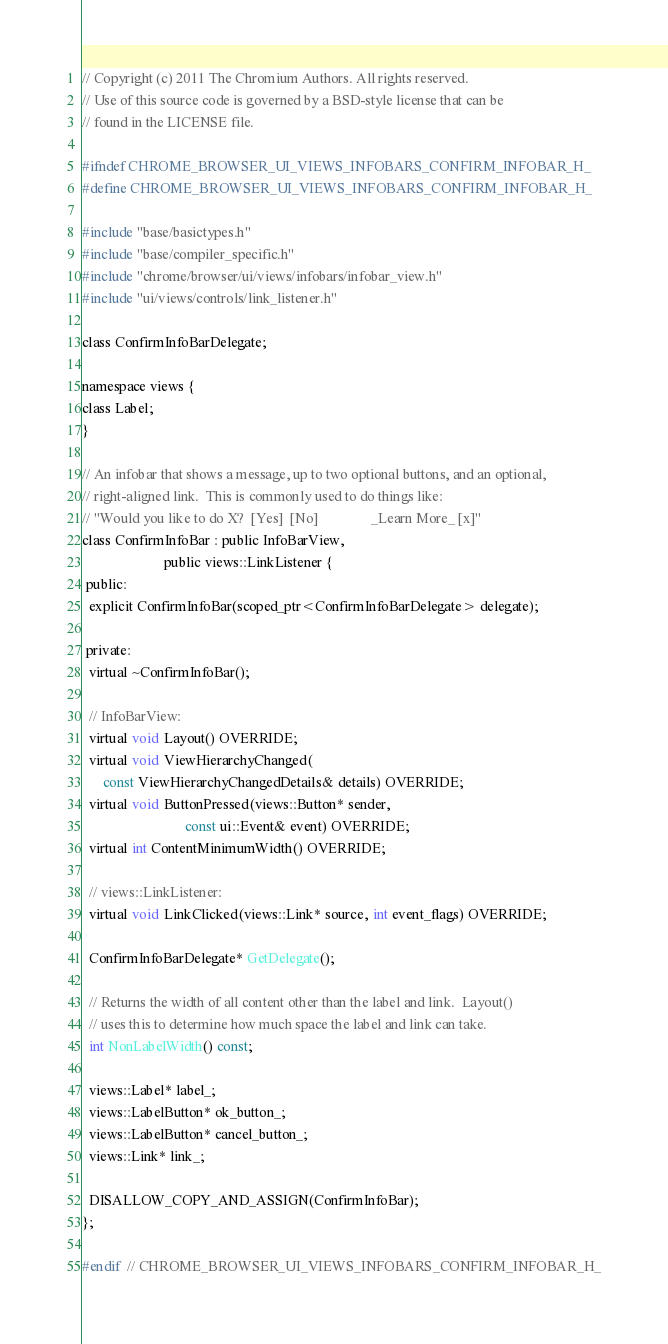<code> <loc_0><loc_0><loc_500><loc_500><_C_>// Copyright (c) 2011 The Chromium Authors. All rights reserved.
// Use of this source code is governed by a BSD-style license that can be
// found in the LICENSE file.

#ifndef CHROME_BROWSER_UI_VIEWS_INFOBARS_CONFIRM_INFOBAR_H_
#define CHROME_BROWSER_UI_VIEWS_INFOBARS_CONFIRM_INFOBAR_H_

#include "base/basictypes.h"
#include "base/compiler_specific.h"
#include "chrome/browser/ui/views/infobars/infobar_view.h"
#include "ui/views/controls/link_listener.h"

class ConfirmInfoBarDelegate;

namespace views {
class Label;
}

// An infobar that shows a message, up to two optional buttons, and an optional,
// right-aligned link.  This is commonly used to do things like:
// "Would you like to do X?  [Yes]  [No]               _Learn More_ [x]"
class ConfirmInfoBar : public InfoBarView,
                       public views::LinkListener {
 public:
  explicit ConfirmInfoBar(scoped_ptr<ConfirmInfoBarDelegate> delegate);

 private:
  virtual ~ConfirmInfoBar();

  // InfoBarView:
  virtual void Layout() OVERRIDE;
  virtual void ViewHierarchyChanged(
      const ViewHierarchyChangedDetails& details) OVERRIDE;
  virtual void ButtonPressed(views::Button* sender,
                             const ui::Event& event) OVERRIDE;
  virtual int ContentMinimumWidth() OVERRIDE;

  // views::LinkListener:
  virtual void LinkClicked(views::Link* source, int event_flags) OVERRIDE;

  ConfirmInfoBarDelegate* GetDelegate();

  // Returns the width of all content other than the label and link.  Layout()
  // uses this to determine how much space the label and link can take.
  int NonLabelWidth() const;

  views::Label* label_;
  views::LabelButton* ok_button_;
  views::LabelButton* cancel_button_;
  views::Link* link_;

  DISALLOW_COPY_AND_ASSIGN(ConfirmInfoBar);
};

#endif  // CHROME_BROWSER_UI_VIEWS_INFOBARS_CONFIRM_INFOBAR_H_
</code> 